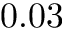<formula> <loc_0><loc_0><loc_500><loc_500>0 . 0 3</formula> 